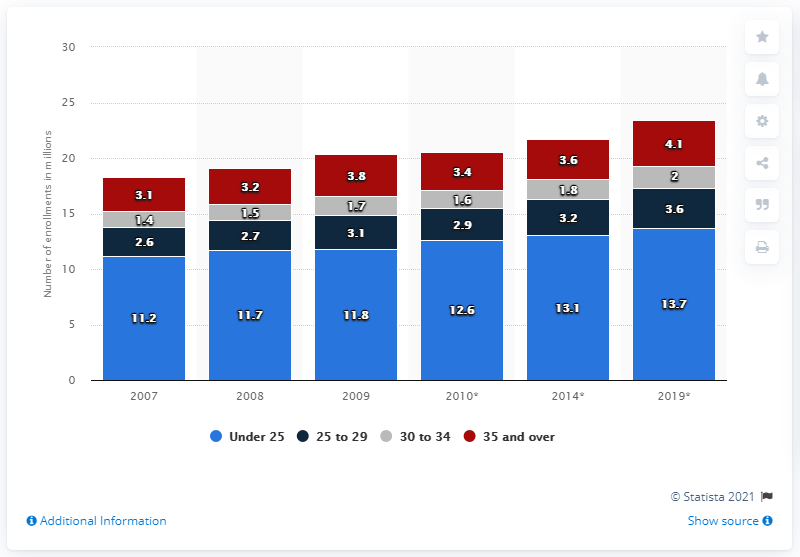Indicate a few pertinent items in this graphic. Approximately 4.1 million people aged 35 and over are expected to enroll in universities and other higher education institutions in the United States in 2019. The total number of enrolled students reached its peak in 2019. There were approximately 5.4 enrolled students over the age of 30 in 2014. 